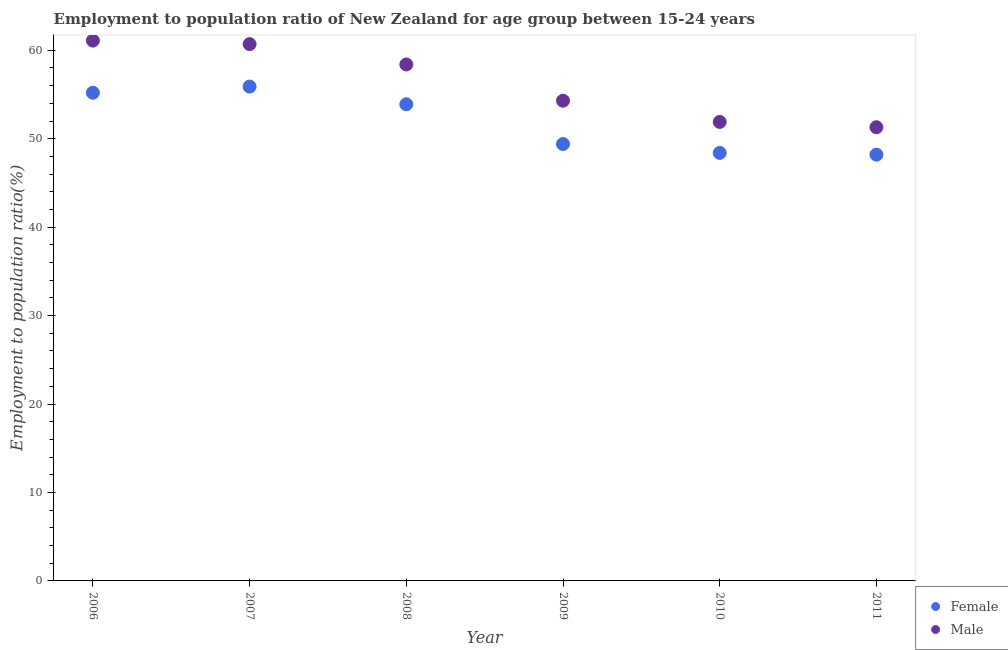What is the employment to population ratio(male) in 2009?
Keep it short and to the point. 54.3. Across all years, what is the maximum employment to population ratio(female)?
Keep it short and to the point. 55.9. Across all years, what is the minimum employment to population ratio(female)?
Offer a very short reply. 48.2. In which year was the employment to population ratio(female) minimum?
Keep it short and to the point. 2011. What is the total employment to population ratio(female) in the graph?
Provide a succinct answer. 311. What is the difference between the employment to population ratio(male) in 2006 and that in 2010?
Keep it short and to the point. 9.2. What is the difference between the employment to population ratio(male) in 2011 and the employment to population ratio(female) in 2008?
Offer a terse response. -2.6. What is the average employment to population ratio(female) per year?
Your answer should be very brief. 51.83. In the year 2008, what is the difference between the employment to population ratio(female) and employment to population ratio(male)?
Keep it short and to the point. -4.5. In how many years, is the employment to population ratio(female) greater than 12 %?
Keep it short and to the point. 6. What is the ratio of the employment to population ratio(female) in 2006 to that in 2007?
Offer a terse response. 0.99. Is the employment to population ratio(female) in 2006 less than that in 2008?
Provide a short and direct response. No. What is the difference between the highest and the second highest employment to population ratio(male)?
Your response must be concise. 0.4. What is the difference between the highest and the lowest employment to population ratio(male)?
Keep it short and to the point. 9.8. In how many years, is the employment to population ratio(male) greater than the average employment to population ratio(male) taken over all years?
Give a very brief answer. 3. Is the sum of the employment to population ratio(male) in 2006 and 2010 greater than the maximum employment to population ratio(female) across all years?
Your answer should be compact. Yes. Is the employment to population ratio(female) strictly greater than the employment to population ratio(male) over the years?
Give a very brief answer. No. Is the employment to population ratio(female) strictly less than the employment to population ratio(male) over the years?
Your response must be concise. Yes. Are the values on the major ticks of Y-axis written in scientific E-notation?
Your answer should be compact. No. Does the graph contain grids?
Offer a very short reply. No. How many legend labels are there?
Keep it short and to the point. 2. What is the title of the graph?
Offer a very short reply. Employment to population ratio of New Zealand for age group between 15-24 years. What is the Employment to population ratio(%) in Female in 2006?
Your answer should be compact. 55.2. What is the Employment to population ratio(%) of Male in 2006?
Keep it short and to the point. 61.1. What is the Employment to population ratio(%) in Female in 2007?
Keep it short and to the point. 55.9. What is the Employment to population ratio(%) in Male in 2007?
Provide a succinct answer. 60.7. What is the Employment to population ratio(%) of Female in 2008?
Offer a terse response. 53.9. What is the Employment to population ratio(%) in Male in 2008?
Provide a short and direct response. 58.4. What is the Employment to population ratio(%) in Female in 2009?
Give a very brief answer. 49.4. What is the Employment to population ratio(%) of Male in 2009?
Provide a succinct answer. 54.3. What is the Employment to population ratio(%) of Female in 2010?
Keep it short and to the point. 48.4. What is the Employment to population ratio(%) in Male in 2010?
Your answer should be compact. 51.9. What is the Employment to population ratio(%) in Female in 2011?
Give a very brief answer. 48.2. What is the Employment to population ratio(%) in Male in 2011?
Offer a terse response. 51.3. Across all years, what is the maximum Employment to population ratio(%) in Female?
Provide a succinct answer. 55.9. Across all years, what is the maximum Employment to population ratio(%) of Male?
Ensure brevity in your answer.  61.1. Across all years, what is the minimum Employment to population ratio(%) in Female?
Your answer should be very brief. 48.2. Across all years, what is the minimum Employment to population ratio(%) of Male?
Give a very brief answer. 51.3. What is the total Employment to population ratio(%) of Female in the graph?
Provide a succinct answer. 311. What is the total Employment to population ratio(%) in Male in the graph?
Offer a very short reply. 337.7. What is the difference between the Employment to population ratio(%) of Female in 2006 and that in 2010?
Give a very brief answer. 6.8. What is the difference between the Employment to population ratio(%) of Male in 2006 and that in 2010?
Your response must be concise. 9.2. What is the difference between the Employment to population ratio(%) in Female in 2006 and that in 2011?
Offer a very short reply. 7. What is the difference between the Employment to population ratio(%) of Male in 2006 and that in 2011?
Provide a succinct answer. 9.8. What is the difference between the Employment to population ratio(%) in Female in 2007 and that in 2009?
Keep it short and to the point. 6.5. What is the difference between the Employment to population ratio(%) in Female in 2007 and that in 2010?
Ensure brevity in your answer.  7.5. What is the difference between the Employment to population ratio(%) of Female in 2008 and that in 2010?
Make the answer very short. 5.5. What is the difference between the Employment to population ratio(%) in Male in 2008 and that in 2010?
Make the answer very short. 6.5. What is the difference between the Employment to population ratio(%) of Female in 2009 and that in 2011?
Your response must be concise. 1.2. What is the difference between the Employment to population ratio(%) in Male in 2009 and that in 2011?
Offer a very short reply. 3. What is the difference between the Employment to population ratio(%) of Male in 2010 and that in 2011?
Ensure brevity in your answer.  0.6. What is the difference between the Employment to population ratio(%) in Female in 2006 and the Employment to population ratio(%) in Male in 2009?
Your response must be concise. 0.9. What is the difference between the Employment to population ratio(%) in Female in 2006 and the Employment to population ratio(%) in Male in 2010?
Provide a succinct answer. 3.3. What is the difference between the Employment to population ratio(%) in Female in 2006 and the Employment to population ratio(%) in Male in 2011?
Your response must be concise. 3.9. What is the difference between the Employment to population ratio(%) in Female in 2007 and the Employment to population ratio(%) in Male in 2008?
Your answer should be very brief. -2.5. What is the difference between the Employment to population ratio(%) of Female in 2007 and the Employment to population ratio(%) of Male in 2009?
Your answer should be very brief. 1.6. What is the difference between the Employment to population ratio(%) of Female in 2007 and the Employment to population ratio(%) of Male in 2010?
Give a very brief answer. 4. What is the difference between the Employment to population ratio(%) in Female in 2007 and the Employment to population ratio(%) in Male in 2011?
Provide a succinct answer. 4.6. What is the difference between the Employment to population ratio(%) in Female in 2008 and the Employment to population ratio(%) in Male in 2011?
Your response must be concise. 2.6. What is the difference between the Employment to population ratio(%) in Female in 2009 and the Employment to population ratio(%) in Male in 2010?
Your response must be concise. -2.5. What is the average Employment to population ratio(%) in Female per year?
Give a very brief answer. 51.83. What is the average Employment to population ratio(%) of Male per year?
Your response must be concise. 56.28. In the year 2007, what is the difference between the Employment to population ratio(%) in Female and Employment to population ratio(%) in Male?
Offer a terse response. -4.8. In the year 2008, what is the difference between the Employment to population ratio(%) in Female and Employment to population ratio(%) in Male?
Offer a very short reply. -4.5. In the year 2009, what is the difference between the Employment to population ratio(%) in Female and Employment to population ratio(%) in Male?
Offer a very short reply. -4.9. In the year 2011, what is the difference between the Employment to population ratio(%) of Female and Employment to population ratio(%) of Male?
Offer a very short reply. -3.1. What is the ratio of the Employment to population ratio(%) of Female in 2006 to that in 2007?
Ensure brevity in your answer.  0.99. What is the ratio of the Employment to population ratio(%) in Male in 2006 to that in 2007?
Give a very brief answer. 1.01. What is the ratio of the Employment to population ratio(%) in Female in 2006 to that in 2008?
Your answer should be compact. 1.02. What is the ratio of the Employment to population ratio(%) of Male in 2006 to that in 2008?
Provide a short and direct response. 1.05. What is the ratio of the Employment to population ratio(%) in Female in 2006 to that in 2009?
Offer a very short reply. 1.12. What is the ratio of the Employment to population ratio(%) in Male in 2006 to that in 2009?
Offer a terse response. 1.13. What is the ratio of the Employment to population ratio(%) of Female in 2006 to that in 2010?
Keep it short and to the point. 1.14. What is the ratio of the Employment to population ratio(%) of Male in 2006 to that in 2010?
Provide a short and direct response. 1.18. What is the ratio of the Employment to population ratio(%) of Female in 2006 to that in 2011?
Give a very brief answer. 1.15. What is the ratio of the Employment to population ratio(%) in Male in 2006 to that in 2011?
Provide a short and direct response. 1.19. What is the ratio of the Employment to population ratio(%) in Female in 2007 to that in 2008?
Make the answer very short. 1.04. What is the ratio of the Employment to population ratio(%) in Male in 2007 to that in 2008?
Offer a terse response. 1.04. What is the ratio of the Employment to population ratio(%) in Female in 2007 to that in 2009?
Your answer should be compact. 1.13. What is the ratio of the Employment to population ratio(%) of Male in 2007 to that in 2009?
Make the answer very short. 1.12. What is the ratio of the Employment to population ratio(%) in Female in 2007 to that in 2010?
Offer a very short reply. 1.16. What is the ratio of the Employment to population ratio(%) in Male in 2007 to that in 2010?
Ensure brevity in your answer.  1.17. What is the ratio of the Employment to population ratio(%) of Female in 2007 to that in 2011?
Offer a terse response. 1.16. What is the ratio of the Employment to population ratio(%) of Male in 2007 to that in 2011?
Keep it short and to the point. 1.18. What is the ratio of the Employment to population ratio(%) in Female in 2008 to that in 2009?
Your response must be concise. 1.09. What is the ratio of the Employment to population ratio(%) in Male in 2008 to that in 2009?
Offer a terse response. 1.08. What is the ratio of the Employment to population ratio(%) of Female in 2008 to that in 2010?
Your answer should be very brief. 1.11. What is the ratio of the Employment to population ratio(%) of Male in 2008 to that in 2010?
Give a very brief answer. 1.13. What is the ratio of the Employment to population ratio(%) of Female in 2008 to that in 2011?
Your answer should be compact. 1.12. What is the ratio of the Employment to population ratio(%) of Male in 2008 to that in 2011?
Provide a short and direct response. 1.14. What is the ratio of the Employment to population ratio(%) in Female in 2009 to that in 2010?
Your response must be concise. 1.02. What is the ratio of the Employment to population ratio(%) of Male in 2009 to that in 2010?
Ensure brevity in your answer.  1.05. What is the ratio of the Employment to population ratio(%) of Female in 2009 to that in 2011?
Offer a terse response. 1.02. What is the ratio of the Employment to population ratio(%) in Male in 2009 to that in 2011?
Your response must be concise. 1.06. What is the ratio of the Employment to population ratio(%) of Female in 2010 to that in 2011?
Your answer should be compact. 1. What is the ratio of the Employment to population ratio(%) of Male in 2010 to that in 2011?
Keep it short and to the point. 1.01. What is the difference between the highest and the second highest Employment to population ratio(%) of Female?
Your answer should be very brief. 0.7. What is the difference between the highest and the second highest Employment to population ratio(%) of Male?
Provide a short and direct response. 0.4. What is the difference between the highest and the lowest Employment to population ratio(%) in Female?
Your response must be concise. 7.7. What is the difference between the highest and the lowest Employment to population ratio(%) in Male?
Ensure brevity in your answer.  9.8. 